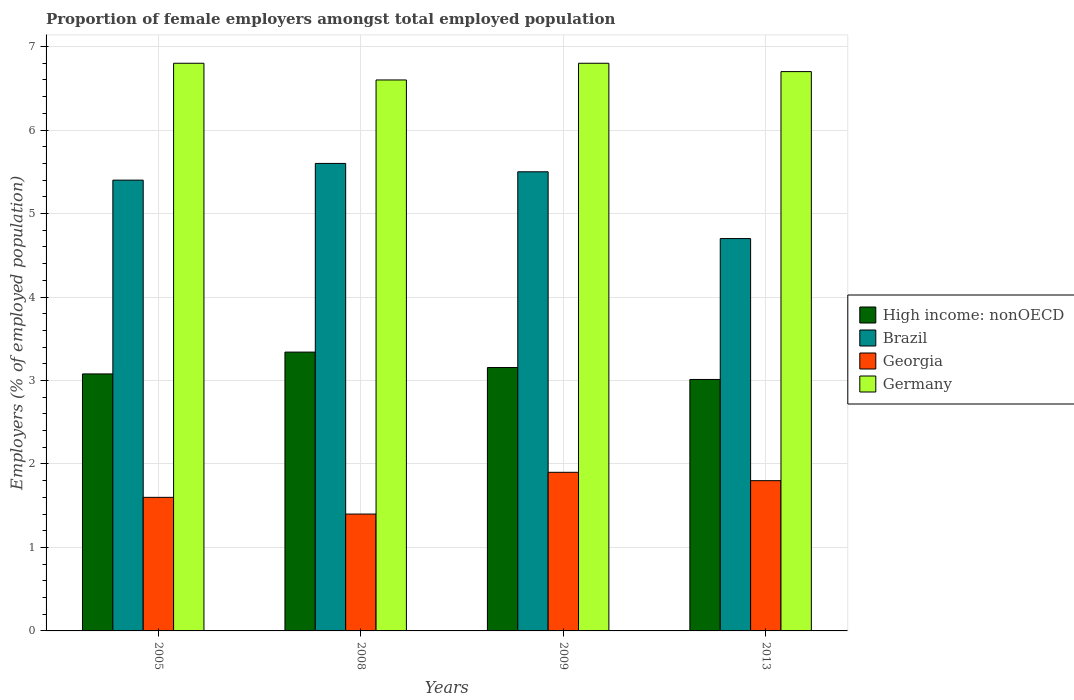Are the number of bars on each tick of the X-axis equal?
Your response must be concise. Yes. How many bars are there on the 4th tick from the right?
Offer a terse response. 4. What is the label of the 4th group of bars from the left?
Offer a terse response. 2013. What is the proportion of female employers in Georgia in 2009?
Offer a terse response. 1.9. Across all years, what is the maximum proportion of female employers in Georgia?
Ensure brevity in your answer.  1.9. Across all years, what is the minimum proportion of female employers in Georgia?
Make the answer very short. 1.4. In which year was the proportion of female employers in Germany maximum?
Your answer should be very brief. 2005. What is the total proportion of female employers in Georgia in the graph?
Keep it short and to the point. 6.7. What is the difference between the proportion of female employers in Brazil in 2005 and that in 2013?
Keep it short and to the point. 0.7. What is the difference between the proportion of female employers in Georgia in 2009 and the proportion of female employers in High income: nonOECD in 2013?
Your response must be concise. -1.11. What is the average proportion of female employers in Germany per year?
Keep it short and to the point. 6.73. In the year 2013, what is the difference between the proportion of female employers in Georgia and proportion of female employers in High income: nonOECD?
Your answer should be compact. -1.21. What is the ratio of the proportion of female employers in Brazil in 2005 to that in 2008?
Ensure brevity in your answer.  0.96. Is the proportion of female employers in Georgia in 2005 less than that in 2009?
Provide a succinct answer. Yes. What is the difference between the highest and the second highest proportion of female employers in Germany?
Provide a short and direct response. 0. What is the difference between the highest and the lowest proportion of female employers in High income: nonOECD?
Your response must be concise. 0.33. Is the sum of the proportion of female employers in High income: nonOECD in 2009 and 2013 greater than the maximum proportion of female employers in Georgia across all years?
Your answer should be very brief. Yes. What does the 1st bar from the left in 2013 represents?
Make the answer very short. High income: nonOECD. What does the 3rd bar from the right in 2005 represents?
Give a very brief answer. Brazil. Is it the case that in every year, the sum of the proportion of female employers in Georgia and proportion of female employers in Germany is greater than the proportion of female employers in Brazil?
Keep it short and to the point. Yes. How many bars are there?
Your response must be concise. 16. How many years are there in the graph?
Give a very brief answer. 4. What is the difference between two consecutive major ticks on the Y-axis?
Ensure brevity in your answer.  1. What is the title of the graph?
Offer a terse response. Proportion of female employers amongst total employed population. Does "Cabo Verde" appear as one of the legend labels in the graph?
Give a very brief answer. No. What is the label or title of the X-axis?
Give a very brief answer. Years. What is the label or title of the Y-axis?
Your answer should be compact. Employers (% of employed population). What is the Employers (% of employed population) of High income: nonOECD in 2005?
Offer a very short reply. 3.08. What is the Employers (% of employed population) of Brazil in 2005?
Provide a succinct answer. 5.4. What is the Employers (% of employed population) in Georgia in 2005?
Give a very brief answer. 1.6. What is the Employers (% of employed population) of Germany in 2005?
Give a very brief answer. 6.8. What is the Employers (% of employed population) of High income: nonOECD in 2008?
Ensure brevity in your answer.  3.34. What is the Employers (% of employed population) of Brazil in 2008?
Your answer should be compact. 5.6. What is the Employers (% of employed population) in Georgia in 2008?
Your answer should be very brief. 1.4. What is the Employers (% of employed population) of Germany in 2008?
Offer a very short reply. 6.6. What is the Employers (% of employed population) in High income: nonOECD in 2009?
Give a very brief answer. 3.16. What is the Employers (% of employed population) in Georgia in 2009?
Provide a succinct answer. 1.9. What is the Employers (% of employed population) in Germany in 2009?
Your answer should be very brief. 6.8. What is the Employers (% of employed population) of High income: nonOECD in 2013?
Keep it short and to the point. 3.01. What is the Employers (% of employed population) of Brazil in 2013?
Keep it short and to the point. 4.7. What is the Employers (% of employed population) of Georgia in 2013?
Provide a short and direct response. 1.8. What is the Employers (% of employed population) of Germany in 2013?
Provide a short and direct response. 6.7. Across all years, what is the maximum Employers (% of employed population) of High income: nonOECD?
Your response must be concise. 3.34. Across all years, what is the maximum Employers (% of employed population) of Brazil?
Give a very brief answer. 5.6. Across all years, what is the maximum Employers (% of employed population) in Georgia?
Provide a short and direct response. 1.9. Across all years, what is the maximum Employers (% of employed population) of Germany?
Keep it short and to the point. 6.8. Across all years, what is the minimum Employers (% of employed population) in High income: nonOECD?
Your answer should be very brief. 3.01. Across all years, what is the minimum Employers (% of employed population) of Brazil?
Give a very brief answer. 4.7. Across all years, what is the minimum Employers (% of employed population) of Georgia?
Make the answer very short. 1.4. Across all years, what is the minimum Employers (% of employed population) of Germany?
Offer a very short reply. 6.6. What is the total Employers (% of employed population) of High income: nonOECD in the graph?
Provide a succinct answer. 12.59. What is the total Employers (% of employed population) in Brazil in the graph?
Provide a short and direct response. 21.2. What is the total Employers (% of employed population) in Germany in the graph?
Give a very brief answer. 26.9. What is the difference between the Employers (% of employed population) of High income: nonOECD in 2005 and that in 2008?
Offer a very short reply. -0.26. What is the difference between the Employers (% of employed population) in Brazil in 2005 and that in 2008?
Make the answer very short. -0.2. What is the difference between the Employers (% of employed population) in Georgia in 2005 and that in 2008?
Give a very brief answer. 0.2. What is the difference between the Employers (% of employed population) in Germany in 2005 and that in 2008?
Give a very brief answer. 0.2. What is the difference between the Employers (% of employed population) of High income: nonOECD in 2005 and that in 2009?
Offer a very short reply. -0.08. What is the difference between the Employers (% of employed population) in Germany in 2005 and that in 2009?
Your response must be concise. 0. What is the difference between the Employers (% of employed population) in High income: nonOECD in 2005 and that in 2013?
Make the answer very short. 0.07. What is the difference between the Employers (% of employed population) of High income: nonOECD in 2008 and that in 2009?
Give a very brief answer. 0.18. What is the difference between the Employers (% of employed population) of Brazil in 2008 and that in 2009?
Give a very brief answer. 0.1. What is the difference between the Employers (% of employed population) of Georgia in 2008 and that in 2009?
Give a very brief answer. -0.5. What is the difference between the Employers (% of employed population) of Germany in 2008 and that in 2009?
Give a very brief answer. -0.2. What is the difference between the Employers (% of employed population) in High income: nonOECD in 2008 and that in 2013?
Keep it short and to the point. 0.33. What is the difference between the Employers (% of employed population) in Brazil in 2008 and that in 2013?
Your answer should be very brief. 0.9. What is the difference between the Employers (% of employed population) of Georgia in 2008 and that in 2013?
Keep it short and to the point. -0.4. What is the difference between the Employers (% of employed population) in High income: nonOECD in 2009 and that in 2013?
Provide a succinct answer. 0.14. What is the difference between the Employers (% of employed population) of Germany in 2009 and that in 2013?
Give a very brief answer. 0.1. What is the difference between the Employers (% of employed population) of High income: nonOECD in 2005 and the Employers (% of employed population) of Brazil in 2008?
Your answer should be very brief. -2.52. What is the difference between the Employers (% of employed population) in High income: nonOECD in 2005 and the Employers (% of employed population) in Georgia in 2008?
Your answer should be very brief. 1.68. What is the difference between the Employers (% of employed population) of High income: nonOECD in 2005 and the Employers (% of employed population) of Germany in 2008?
Provide a succinct answer. -3.52. What is the difference between the Employers (% of employed population) in Brazil in 2005 and the Employers (% of employed population) in Germany in 2008?
Your answer should be very brief. -1.2. What is the difference between the Employers (% of employed population) in High income: nonOECD in 2005 and the Employers (% of employed population) in Brazil in 2009?
Keep it short and to the point. -2.42. What is the difference between the Employers (% of employed population) of High income: nonOECD in 2005 and the Employers (% of employed population) of Georgia in 2009?
Your answer should be very brief. 1.18. What is the difference between the Employers (% of employed population) of High income: nonOECD in 2005 and the Employers (% of employed population) of Germany in 2009?
Offer a terse response. -3.72. What is the difference between the Employers (% of employed population) of Brazil in 2005 and the Employers (% of employed population) of Georgia in 2009?
Ensure brevity in your answer.  3.5. What is the difference between the Employers (% of employed population) in Georgia in 2005 and the Employers (% of employed population) in Germany in 2009?
Make the answer very short. -5.2. What is the difference between the Employers (% of employed population) in High income: nonOECD in 2005 and the Employers (% of employed population) in Brazil in 2013?
Make the answer very short. -1.62. What is the difference between the Employers (% of employed population) in High income: nonOECD in 2005 and the Employers (% of employed population) in Georgia in 2013?
Your answer should be very brief. 1.28. What is the difference between the Employers (% of employed population) of High income: nonOECD in 2005 and the Employers (% of employed population) of Germany in 2013?
Offer a very short reply. -3.62. What is the difference between the Employers (% of employed population) of Brazil in 2005 and the Employers (% of employed population) of Georgia in 2013?
Provide a succinct answer. 3.6. What is the difference between the Employers (% of employed population) of Brazil in 2005 and the Employers (% of employed population) of Germany in 2013?
Your response must be concise. -1.3. What is the difference between the Employers (% of employed population) of Georgia in 2005 and the Employers (% of employed population) of Germany in 2013?
Your answer should be compact. -5.1. What is the difference between the Employers (% of employed population) in High income: nonOECD in 2008 and the Employers (% of employed population) in Brazil in 2009?
Offer a terse response. -2.16. What is the difference between the Employers (% of employed population) of High income: nonOECD in 2008 and the Employers (% of employed population) of Georgia in 2009?
Keep it short and to the point. 1.44. What is the difference between the Employers (% of employed population) in High income: nonOECD in 2008 and the Employers (% of employed population) in Germany in 2009?
Provide a short and direct response. -3.46. What is the difference between the Employers (% of employed population) in Brazil in 2008 and the Employers (% of employed population) in Germany in 2009?
Keep it short and to the point. -1.2. What is the difference between the Employers (% of employed population) of High income: nonOECD in 2008 and the Employers (% of employed population) of Brazil in 2013?
Provide a short and direct response. -1.36. What is the difference between the Employers (% of employed population) of High income: nonOECD in 2008 and the Employers (% of employed population) of Georgia in 2013?
Offer a very short reply. 1.54. What is the difference between the Employers (% of employed population) in High income: nonOECD in 2008 and the Employers (% of employed population) in Germany in 2013?
Offer a very short reply. -3.36. What is the difference between the Employers (% of employed population) of Brazil in 2008 and the Employers (% of employed population) of Georgia in 2013?
Your answer should be compact. 3.8. What is the difference between the Employers (% of employed population) of High income: nonOECD in 2009 and the Employers (% of employed population) of Brazil in 2013?
Provide a succinct answer. -1.54. What is the difference between the Employers (% of employed population) in High income: nonOECD in 2009 and the Employers (% of employed population) in Georgia in 2013?
Provide a short and direct response. 1.35. What is the difference between the Employers (% of employed population) of High income: nonOECD in 2009 and the Employers (% of employed population) of Germany in 2013?
Your answer should be compact. -3.54. What is the difference between the Employers (% of employed population) of Brazil in 2009 and the Employers (% of employed population) of Germany in 2013?
Ensure brevity in your answer.  -1.2. What is the difference between the Employers (% of employed population) in Georgia in 2009 and the Employers (% of employed population) in Germany in 2013?
Provide a short and direct response. -4.8. What is the average Employers (% of employed population) of High income: nonOECD per year?
Your answer should be compact. 3.15. What is the average Employers (% of employed population) in Brazil per year?
Give a very brief answer. 5.3. What is the average Employers (% of employed population) of Georgia per year?
Keep it short and to the point. 1.68. What is the average Employers (% of employed population) of Germany per year?
Make the answer very short. 6.72. In the year 2005, what is the difference between the Employers (% of employed population) in High income: nonOECD and Employers (% of employed population) in Brazil?
Provide a short and direct response. -2.32. In the year 2005, what is the difference between the Employers (% of employed population) of High income: nonOECD and Employers (% of employed population) of Georgia?
Make the answer very short. 1.48. In the year 2005, what is the difference between the Employers (% of employed population) in High income: nonOECD and Employers (% of employed population) in Germany?
Your answer should be very brief. -3.72. In the year 2008, what is the difference between the Employers (% of employed population) of High income: nonOECD and Employers (% of employed population) of Brazil?
Your response must be concise. -2.26. In the year 2008, what is the difference between the Employers (% of employed population) of High income: nonOECD and Employers (% of employed population) of Georgia?
Your response must be concise. 1.94. In the year 2008, what is the difference between the Employers (% of employed population) of High income: nonOECD and Employers (% of employed population) of Germany?
Offer a very short reply. -3.26. In the year 2008, what is the difference between the Employers (% of employed population) in Georgia and Employers (% of employed population) in Germany?
Ensure brevity in your answer.  -5.2. In the year 2009, what is the difference between the Employers (% of employed population) in High income: nonOECD and Employers (% of employed population) in Brazil?
Provide a short and direct response. -2.35. In the year 2009, what is the difference between the Employers (% of employed population) of High income: nonOECD and Employers (% of employed population) of Georgia?
Provide a short and direct response. 1.25. In the year 2009, what is the difference between the Employers (% of employed population) of High income: nonOECD and Employers (% of employed population) of Germany?
Offer a terse response. -3.65. In the year 2009, what is the difference between the Employers (% of employed population) in Brazil and Employers (% of employed population) in Germany?
Make the answer very short. -1.3. In the year 2009, what is the difference between the Employers (% of employed population) of Georgia and Employers (% of employed population) of Germany?
Offer a very short reply. -4.9. In the year 2013, what is the difference between the Employers (% of employed population) of High income: nonOECD and Employers (% of employed population) of Brazil?
Provide a succinct answer. -1.69. In the year 2013, what is the difference between the Employers (% of employed population) in High income: nonOECD and Employers (% of employed population) in Georgia?
Provide a succinct answer. 1.21. In the year 2013, what is the difference between the Employers (% of employed population) in High income: nonOECD and Employers (% of employed population) in Germany?
Offer a very short reply. -3.69. In the year 2013, what is the difference between the Employers (% of employed population) of Brazil and Employers (% of employed population) of Georgia?
Offer a terse response. 2.9. In the year 2013, what is the difference between the Employers (% of employed population) in Brazil and Employers (% of employed population) in Germany?
Your response must be concise. -2. In the year 2013, what is the difference between the Employers (% of employed population) in Georgia and Employers (% of employed population) in Germany?
Give a very brief answer. -4.9. What is the ratio of the Employers (% of employed population) of High income: nonOECD in 2005 to that in 2008?
Make the answer very short. 0.92. What is the ratio of the Employers (% of employed population) of Brazil in 2005 to that in 2008?
Your answer should be compact. 0.96. What is the ratio of the Employers (% of employed population) in Germany in 2005 to that in 2008?
Make the answer very short. 1.03. What is the ratio of the Employers (% of employed population) of High income: nonOECD in 2005 to that in 2009?
Provide a succinct answer. 0.98. What is the ratio of the Employers (% of employed population) of Brazil in 2005 to that in 2009?
Offer a very short reply. 0.98. What is the ratio of the Employers (% of employed population) of Georgia in 2005 to that in 2009?
Offer a terse response. 0.84. What is the ratio of the Employers (% of employed population) in Germany in 2005 to that in 2009?
Make the answer very short. 1. What is the ratio of the Employers (% of employed population) of Brazil in 2005 to that in 2013?
Keep it short and to the point. 1.15. What is the ratio of the Employers (% of employed population) in Germany in 2005 to that in 2013?
Your answer should be very brief. 1.01. What is the ratio of the Employers (% of employed population) of High income: nonOECD in 2008 to that in 2009?
Offer a terse response. 1.06. What is the ratio of the Employers (% of employed population) of Brazil in 2008 to that in 2009?
Your answer should be compact. 1.02. What is the ratio of the Employers (% of employed population) in Georgia in 2008 to that in 2009?
Your response must be concise. 0.74. What is the ratio of the Employers (% of employed population) in Germany in 2008 to that in 2009?
Your answer should be very brief. 0.97. What is the ratio of the Employers (% of employed population) in High income: nonOECD in 2008 to that in 2013?
Your response must be concise. 1.11. What is the ratio of the Employers (% of employed population) in Brazil in 2008 to that in 2013?
Give a very brief answer. 1.19. What is the ratio of the Employers (% of employed population) of Germany in 2008 to that in 2013?
Offer a terse response. 0.99. What is the ratio of the Employers (% of employed population) in High income: nonOECD in 2009 to that in 2013?
Your answer should be very brief. 1.05. What is the ratio of the Employers (% of employed population) of Brazil in 2009 to that in 2013?
Keep it short and to the point. 1.17. What is the ratio of the Employers (% of employed population) in Georgia in 2009 to that in 2013?
Your response must be concise. 1.06. What is the ratio of the Employers (% of employed population) of Germany in 2009 to that in 2013?
Provide a succinct answer. 1.01. What is the difference between the highest and the second highest Employers (% of employed population) in High income: nonOECD?
Ensure brevity in your answer.  0.18. What is the difference between the highest and the second highest Employers (% of employed population) of Germany?
Offer a very short reply. 0. What is the difference between the highest and the lowest Employers (% of employed population) in High income: nonOECD?
Make the answer very short. 0.33. What is the difference between the highest and the lowest Employers (% of employed population) of Brazil?
Make the answer very short. 0.9. 